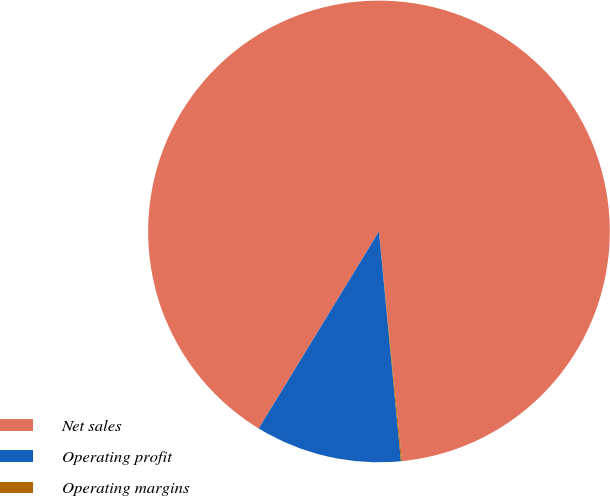Convert chart to OTSL. <chart><loc_0><loc_0><loc_500><loc_500><pie_chart><fcel>Net sales<fcel>Operating profit<fcel>Operating margins<nl><fcel>89.69%<fcel>10.24%<fcel>0.07%<nl></chart> 